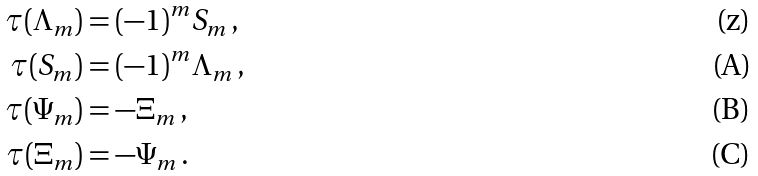<formula> <loc_0><loc_0><loc_500><loc_500>\tau ( \Lambda _ { m } ) & = ( - 1 ) ^ { m } S _ { m } \, , \\ \tau ( S _ { m } ) & = ( - 1 ) ^ { m } \Lambda _ { m } \, , \\ \tau ( \Psi _ { m } ) & = - \Xi _ { m } \, , \\ \tau ( \Xi _ { m } ) & = - \Psi _ { m } \, .</formula> 